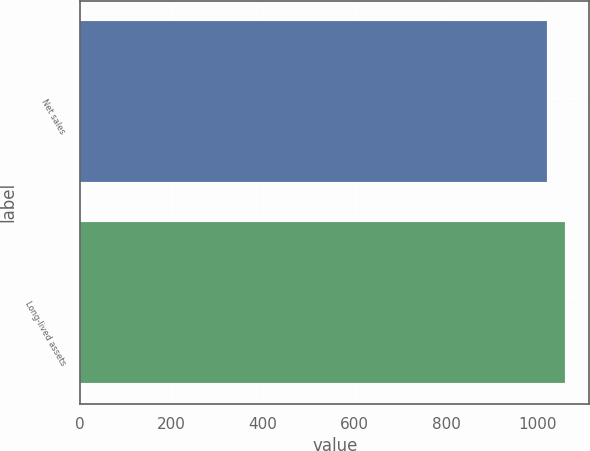<chart> <loc_0><loc_0><loc_500><loc_500><bar_chart><fcel>Net sales<fcel>Long-lived assets<nl><fcel>1021.1<fcel>1060<nl></chart> 